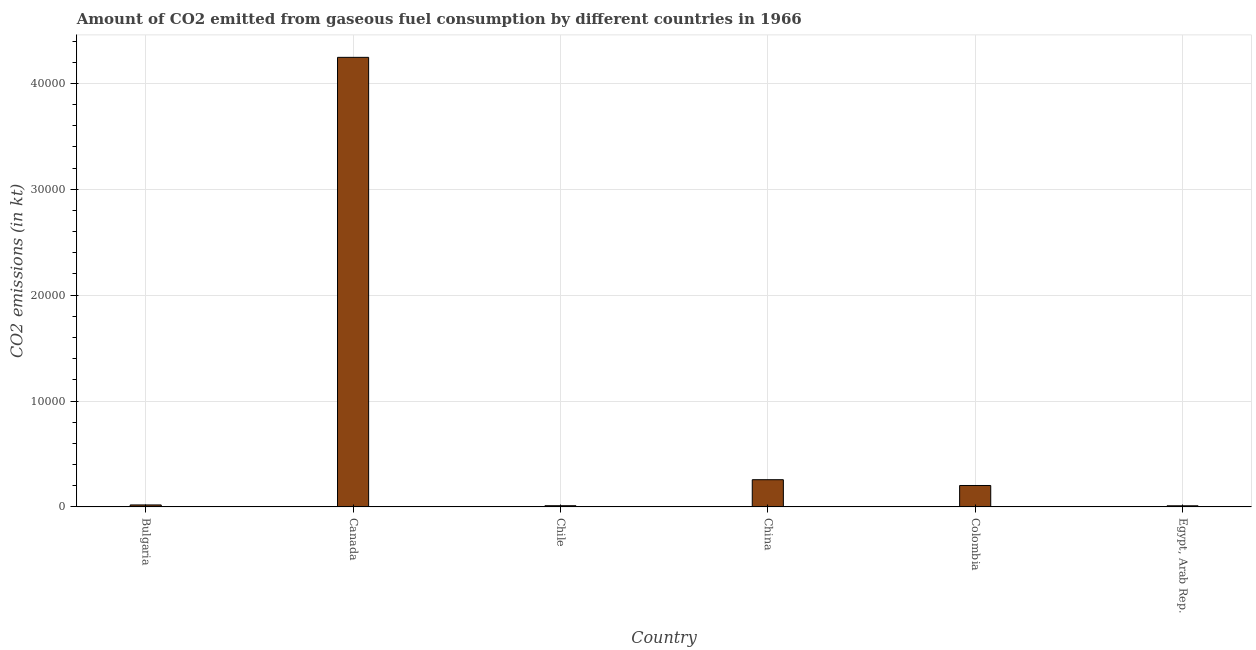Does the graph contain any zero values?
Your response must be concise. No. Does the graph contain grids?
Offer a very short reply. Yes. What is the title of the graph?
Offer a terse response. Amount of CO2 emitted from gaseous fuel consumption by different countries in 1966. What is the label or title of the Y-axis?
Offer a very short reply. CO2 emissions (in kt). What is the co2 emissions from gaseous fuel consumption in Canada?
Your response must be concise. 4.25e+04. Across all countries, what is the maximum co2 emissions from gaseous fuel consumption?
Your answer should be compact. 4.25e+04. Across all countries, what is the minimum co2 emissions from gaseous fuel consumption?
Provide a short and direct response. 106.34. In which country was the co2 emissions from gaseous fuel consumption maximum?
Your answer should be compact. Canada. In which country was the co2 emissions from gaseous fuel consumption minimum?
Keep it short and to the point. Egypt, Arab Rep. What is the sum of the co2 emissions from gaseous fuel consumption?
Offer a very short reply. 4.75e+04. What is the difference between the co2 emissions from gaseous fuel consumption in Bulgaria and Egypt, Arab Rep.?
Your answer should be compact. 80.67. What is the average co2 emissions from gaseous fuel consumption per country?
Make the answer very short. 7909.72. What is the median co2 emissions from gaseous fuel consumption?
Give a very brief answer. 1105.6. What is the ratio of the co2 emissions from gaseous fuel consumption in Canada to that in China?
Offer a terse response. 16.52. Is the co2 emissions from gaseous fuel consumption in Bulgaria less than that in Egypt, Arab Rep.?
Offer a terse response. No. What is the difference between the highest and the second highest co2 emissions from gaseous fuel consumption?
Provide a short and direct response. 3.99e+04. What is the difference between the highest and the lowest co2 emissions from gaseous fuel consumption?
Provide a succinct answer. 4.24e+04. How many bars are there?
Your answer should be compact. 6. Are all the bars in the graph horizontal?
Provide a succinct answer. No. How many countries are there in the graph?
Make the answer very short. 6. What is the difference between two consecutive major ticks on the Y-axis?
Keep it short and to the point. 10000. Are the values on the major ticks of Y-axis written in scientific E-notation?
Offer a terse response. No. What is the CO2 emissions (in kt) in Bulgaria?
Ensure brevity in your answer.  187.02. What is the CO2 emissions (in kt) in Canada?
Ensure brevity in your answer.  4.25e+04. What is the CO2 emissions (in kt) of Chile?
Offer a terse response. 113.68. What is the CO2 emissions (in kt) of China?
Your response must be concise. 2570.57. What is the CO2 emissions (in kt) in Colombia?
Your answer should be compact. 2024.18. What is the CO2 emissions (in kt) of Egypt, Arab Rep.?
Offer a terse response. 106.34. What is the difference between the CO2 emissions (in kt) in Bulgaria and Canada?
Your answer should be compact. -4.23e+04. What is the difference between the CO2 emissions (in kt) in Bulgaria and Chile?
Provide a short and direct response. 73.34. What is the difference between the CO2 emissions (in kt) in Bulgaria and China?
Give a very brief answer. -2383.55. What is the difference between the CO2 emissions (in kt) in Bulgaria and Colombia?
Your answer should be compact. -1837.17. What is the difference between the CO2 emissions (in kt) in Bulgaria and Egypt, Arab Rep.?
Your response must be concise. 80.67. What is the difference between the CO2 emissions (in kt) in Canada and Chile?
Ensure brevity in your answer.  4.23e+04. What is the difference between the CO2 emissions (in kt) in Canada and China?
Provide a short and direct response. 3.99e+04. What is the difference between the CO2 emissions (in kt) in Canada and Colombia?
Ensure brevity in your answer.  4.04e+04. What is the difference between the CO2 emissions (in kt) in Canada and Egypt, Arab Rep.?
Your answer should be very brief. 4.24e+04. What is the difference between the CO2 emissions (in kt) in Chile and China?
Offer a terse response. -2456.89. What is the difference between the CO2 emissions (in kt) in Chile and Colombia?
Your answer should be very brief. -1910.51. What is the difference between the CO2 emissions (in kt) in Chile and Egypt, Arab Rep.?
Offer a very short reply. 7.33. What is the difference between the CO2 emissions (in kt) in China and Colombia?
Your answer should be compact. 546.38. What is the difference between the CO2 emissions (in kt) in China and Egypt, Arab Rep.?
Offer a terse response. 2464.22. What is the difference between the CO2 emissions (in kt) in Colombia and Egypt, Arab Rep.?
Your response must be concise. 1917.84. What is the ratio of the CO2 emissions (in kt) in Bulgaria to that in Canada?
Your response must be concise. 0. What is the ratio of the CO2 emissions (in kt) in Bulgaria to that in Chile?
Give a very brief answer. 1.65. What is the ratio of the CO2 emissions (in kt) in Bulgaria to that in China?
Your response must be concise. 0.07. What is the ratio of the CO2 emissions (in kt) in Bulgaria to that in Colombia?
Provide a succinct answer. 0.09. What is the ratio of the CO2 emissions (in kt) in Bulgaria to that in Egypt, Arab Rep.?
Provide a succinct answer. 1.76. What is the ratio of the CO2 emissions (in kt) in Canada to that in Chile?
Your response must be concise. 373.48. What is the ratio of the CO2 emissions (in kt) in Canada to that in China?
Provide a succinct answer. 16.52. What is the ratio of the CO2 emissions (in kt) in Canada to that in Colombia?
Ensure brevity in your answer.  20.98. What is the ratio of the CO2 emissions (in kt) in Canada to that in Egypt, Arab Rep.?
Offer a very short reply. 399.24. What is the ratio of the CO2 emissions (in kt) in Chile to that in China?
Offer a very short reply. 0.04. What is the ratio of the CO2 emissions (in kt) in Chile to that in Colombia?
Give a very brief answer. 0.06. What is the ratio of the CO2 emissions (in kt) in Chile to that in Egypt, Arab Rep.?
Your answer should be very brief. 1.07. What is the ratio of the CO2 emissions (in kt) in China to that in Colombia?
Keep it short and to the point. 1.27. What is the ratio of the CO2 emissions (in kt) in China to that in Egypt, Arab Rep.?
Provide a short and direct response. 24.17. What is the ratio of the CO2 emissions (in kt) in Colombia to that in Egypt, Arab Rep.?
Provide a succinct answer. 19.03. 